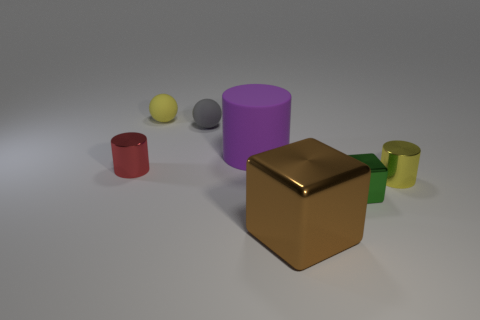The small cylinder on the right side of the metal cylinder to the left of the shiny cylinder on the right side of the large matte cylinder is made of what material?
Your answer should be very brief. Metal. What is the shape of the big brown thing that is the same material as the green block?
Keep it short and to the point. Cube. Is there anything else of the same color as the large block?
Your answer should be compact. No. There is a small shiny thing that is in front of the yellow thing in front of the large matte thing; what number of big brown cubes are on the right side of it?
Your response must be concise. 0. How many blue things are either big cubes or large things?
Provide a succinct answer. 0. Do the purple rubber cylinder and the cylinder that is on the left side of the small gray object have the same size?
Keep it short and to the point. No. There is a big brown object that is the same shape as the green thing; what is it made of?
Provide a short and direct response. Metal. How many other objects are there of the same size as the yellow matte sphere?
Make the answer very short. 4. What shape is the big object that is in front of the small cylinder that is left of the large thing that is in front of the matte cylinder?
Offer a terse response. Cube. There is a thing that is both in front of the gray object and left of the large purple cylinder; what shape is it?
Offer a terse response. Cylinder. 